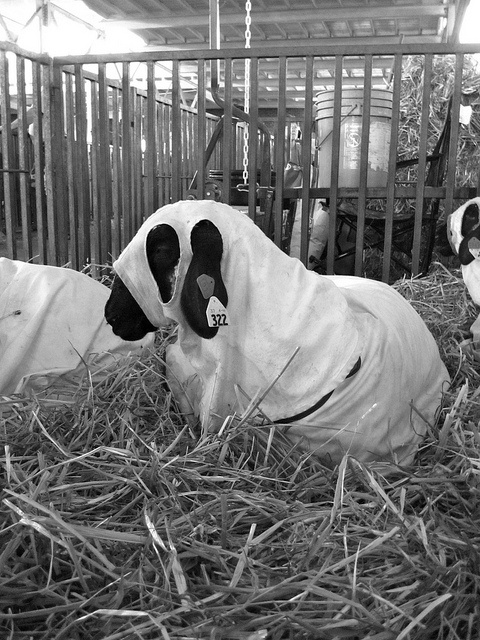Describe the objects in this image and their specific colors. I can see sheep in white, darkgray, lightgray, black, and gray tones, sheep in white, darkgray, lightgray, gray, and black tones, and sheep in white, lightgray, black, darkgray, and gray tones in this image. 